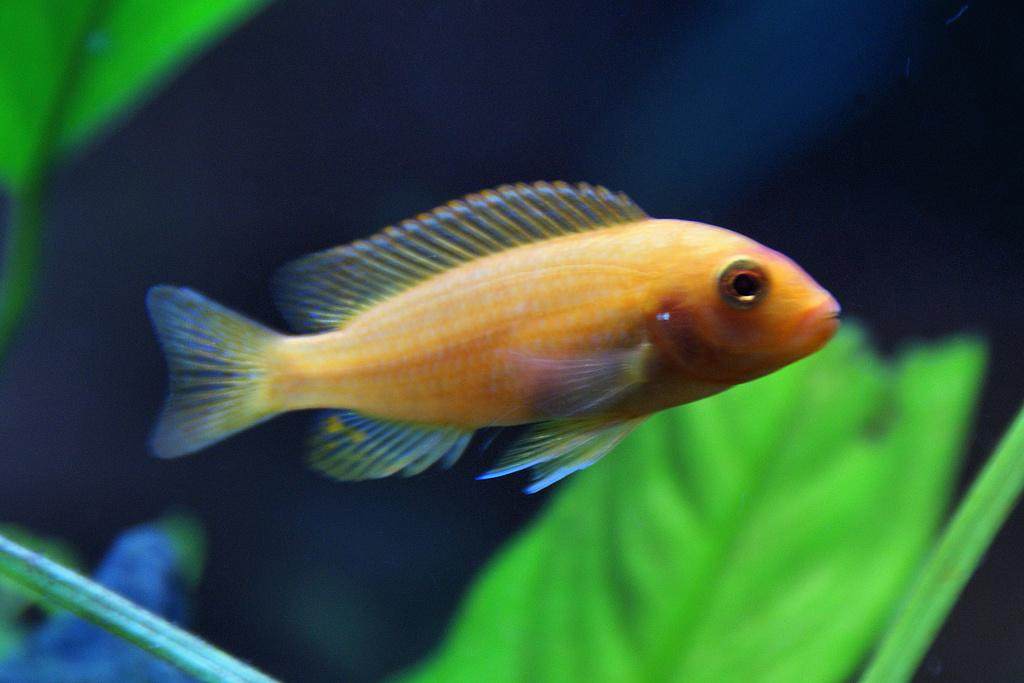What type of animal is in the image? There is a fish in the image. Where is the fish located? The fish is in the water. What type of jam is the fish eating in the image? There is no jam present in the image; the fish is in the water. Is the fish sleeping in the image? The image does not provide information about the fish's state of wakefulness or sleep. 